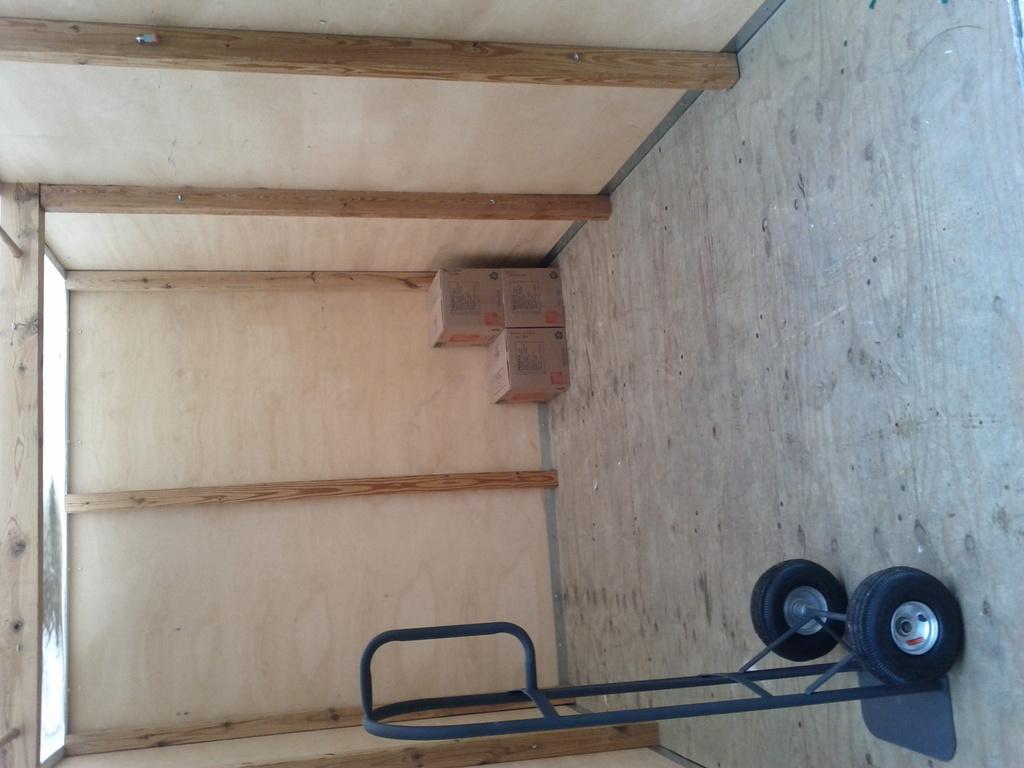Could you give a brief overview of what you see in this image? We can see cart on the floor. Background we can see cardboard boxes and wooden wall. 